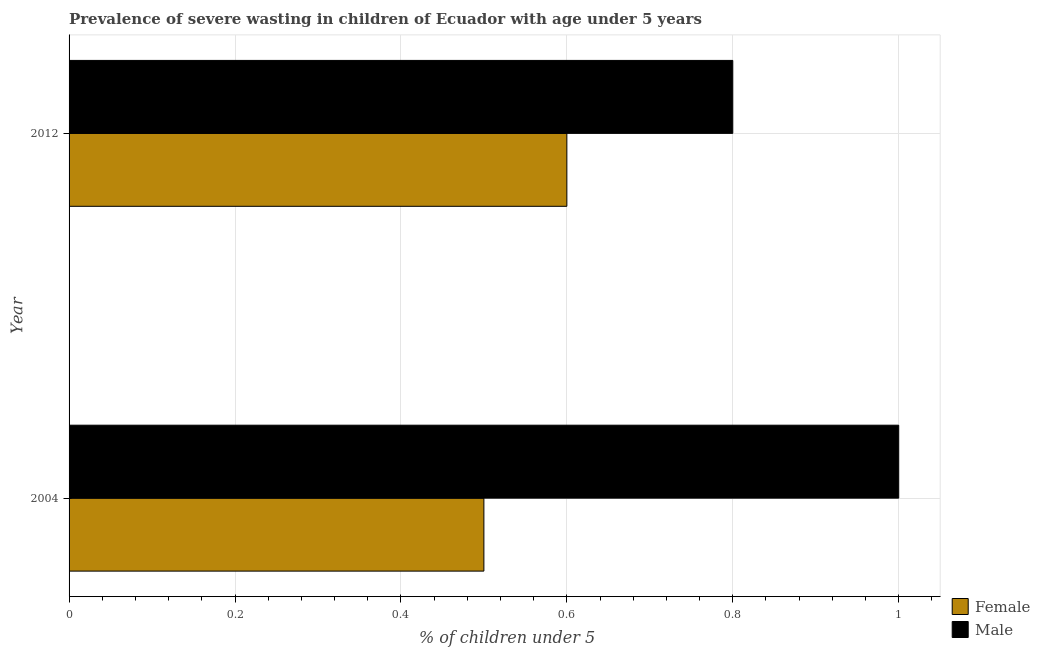Are the number of bars per tick equal to the number of legend labels?
Make the answer very short. Yes. Are the number of bars on each tick of the Y-axis equal?
Your response must be concise. Yes. How many bars are there on the 2nd tick from the top?
Ensure brevity in your answer.  2. What is the percentage of undernourished male children in 2012?
Your answer should be very brief. 0.8. Across all years, what is the maximum percentage of undernourished male children?
Make the answer very short. 1. In which year was the percentage of undernourished male children maximum?
Give a very brief answer. 2004. What is the total percentage of undernourished male children in the graph?
Your answer should be compact. 1.8. What is the difference between the percentage of undernourished male children in 2012 and the percentage of undernourished female children in 2004?
Your answer should be compact. 0.3. What is the average percentage of undernourished male children per year?
Give a very brief answer. 0.9. In how many years, is the percentage of undernourished female children greater than 0.48000000000000004 %?
Your answer should be very brief. 2. What is the ratio of the percentage of undernourished female children in 2004 to that in 2012?
Your response must be concise. 0.83. Is the difference between the percentage of undernourished male children in 2004 and 2012 greater than the difference between the percentage of undernourished female children in 2004 and 2012?
Make the answer very short. Yes. How many bars are there?
Ensure brevity in your answer.  4. How many years are there in the graph?
Give a very brief answer. 2. Does the graph contain any zero values?
Offer a terse response. No. Does the graph contain grids?
Offer a very short reply. Yes. Where does the legend appear in the graph?
Keep it short and to the point. Bottom right. How many legend labels are there?
Your answer should be compact. 2. How are the legend labels stacked?
Keep it short and to the point. Vertical. What is the title of the graph?
Keep it short and to the point. Prevalence of severe wasting in children of Ecuador with age under 5 years. Does "Constant 2005 US$" appear as one of the legend labels in the graph?
Provide a succinct answer. No. What is the label or title of the X-axis?
Provide a succinct answer.  % of children under 5. What is the  % of children under 5 in Female in 2004?
Make the answer very short. 0.5. What is the  % of children under 5 of Female in 2012?
Provide a short and direct response. 0.6. What is the  % of children under 5 in Male in 2012?
Your response must be concise. 0.8. Across all years, what is the maximum  % of children under 5 in Female?
Provide a succinct answer. 0.6. Across all years, what is the minimum  % of children under 5 of Female?
Your answer should be very brief. 0.5. Across all years, what is the minimum  % of children under 5 of Male?
Offer a terse response. 0.8. What is the total  % of children under 5 of Male in the graph?
Offer a very short reply. 1.8. What is the difference between the  % of children under 5 in Male in 2004 and that in 2012?
Offer a very short reply. 0.2. What is the difference between the  % of children under 5 of Female in 2004 and the  % of children under 5 of Male in 2012?
Offer a terse response. -0.3. What is the average  % of children under 5 in Female per year?
Make the answer very short. 0.55. In the year 2004, what is the difference between the  % of children under 5 of Female and  % of children under 5 of Male?
Provide a succinct answer. -0.5. What is the ratio of the  % of children under 5 of Male in 2004 to that in 2012?
Your answer should be very brief. 1.25. What is the difference between the highest and the second highest  % of children under 5 in Male?
Ensure brevity in your answer.  0.2. What is the difference between the highest and the lowest  % of children under 5 in Female?
Provide a succinct answer. 0.1. What is the difference between the highest and the lowest  % of children under 5 of Male?
Give a very brief answer. 0.2. 